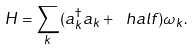<formula> <loc_0><loc_0><loc_500><loc_500>H = \sum _ { k } ( a _ { k } ^ { \dagger } a _ { k } + \ h a l f ) \omega _ { k } .</formula> 